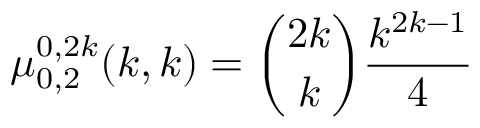<formula> <loc_0><loc_0><loc_500><loc_500>\mu _ { 0 , 2 } ^ { 0 , 2 k } ( k , k ) = { \binom { 2 k } { k } } { \frac { k ^ { 2 k - 1 } } { 4 } }</formula> 